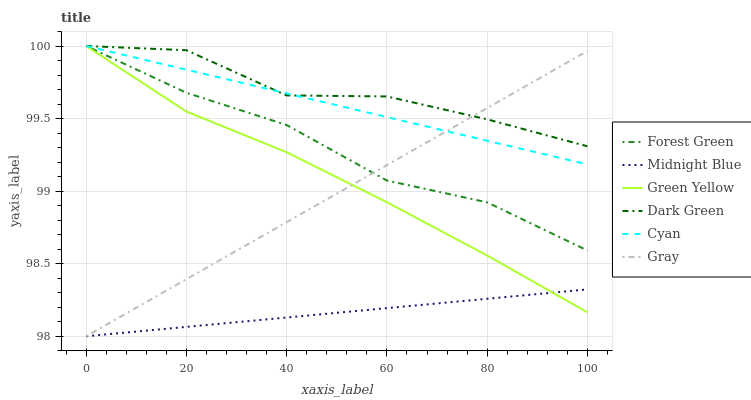Does Midnight Blue have the minimum area under the curve?
Answer yes or no. Yes. Does Dark Green have the maximum area under the curve?
Answer yes or no. Yes. Does Forest Green have the minimum area under the curve?
Answer yes or no. No. Does Forest Green have the maximum area under the curve?
Answer yes or no. No. Is Midnight Blue the smoothest?
Answer yes or no. Yes. Is Dark Green the roughest?
Answer yes or no. Yes. Is Forest Green the smoothest?
Answer yes or no. No. Is Forest Green the roughest?
Answer yes or no. No. Does Forest Green have the lowest value?
Answer yes or no. No. Does Dark Green have the highest value?
Answer yes or no. Yes. Does Midnight Blue have the highest value?
Answer yes or no. No. Is Midnight Blue less than Cyan?
Answer yes or no. Yes. Is Cyan greater than Midnight Blue?
Answer yes or no. Yes. Does Midnight Blue intersect Cyan?
Answer yes or no. No. 